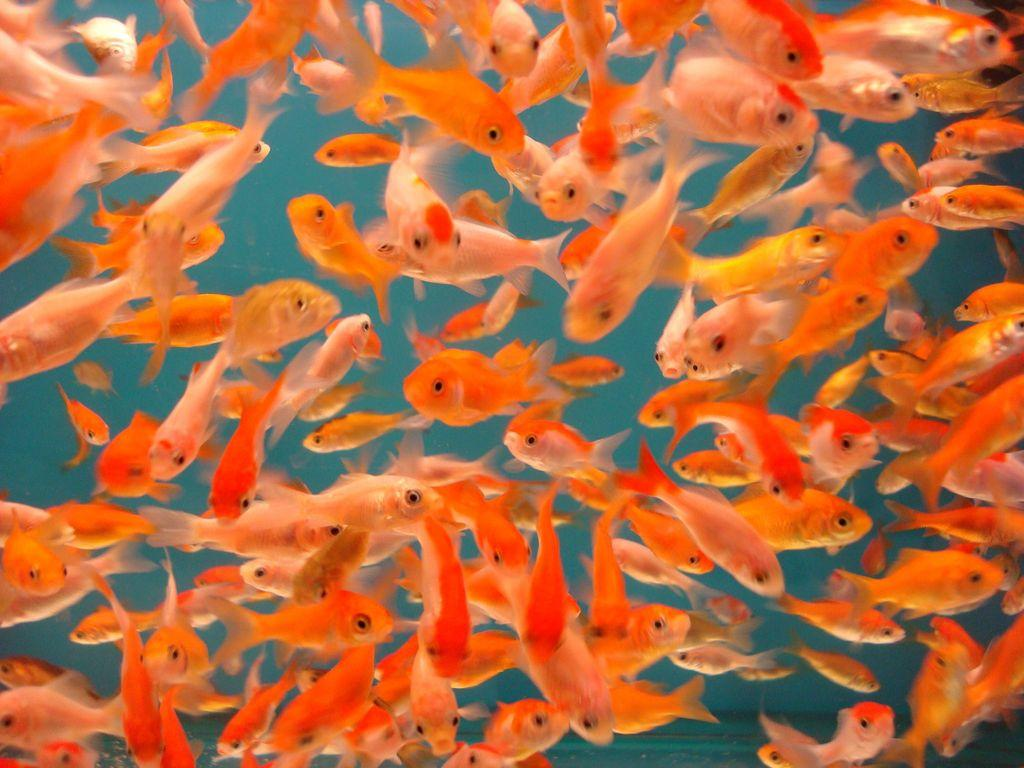What is visible in the image? Water is visible in the image. What can be found in the water? There are fishes in the water. What color are the fishes? The fishes are in orange color. What type of hill can be seen in the background of the image? There is no hill visible in the image; it features water and fishes. How does the brake system work for the fishes in the image? The image does not depict a brake system, as it features water and fishes. 